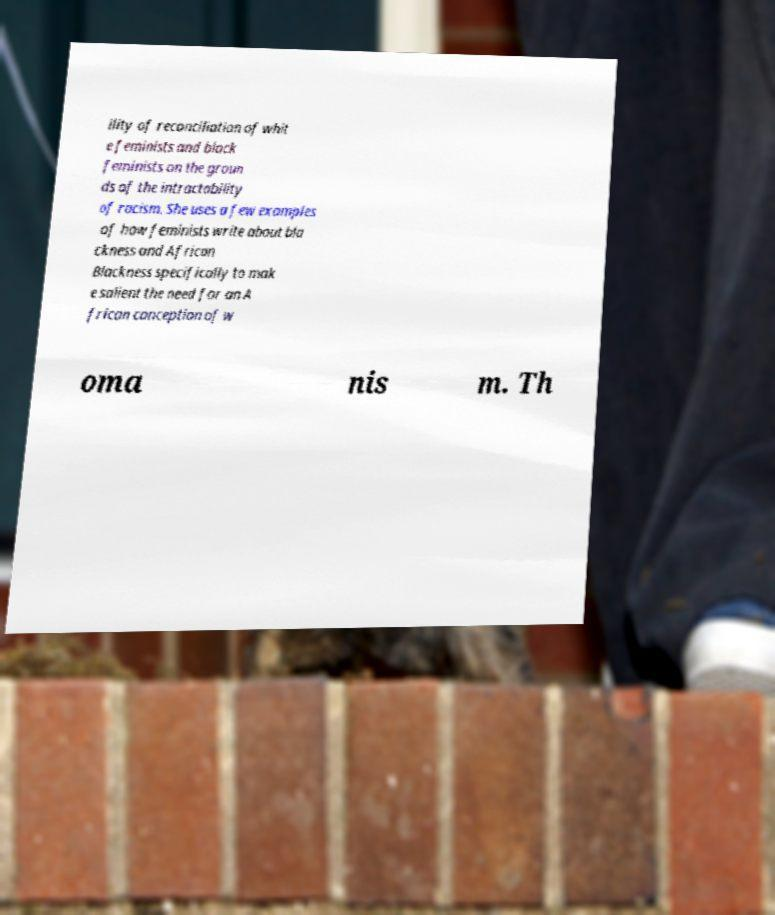Could you assist in decoding the text presented in this image and type it out clearly? ility of reconciliation of whit e feminists and black feminists on the groun ds of the intractability of racism. She uses a few examples of how feminists write about bla ckness and African Blackness specifically to mak e salient the need for an A frican conception of w oma nis m. Th 